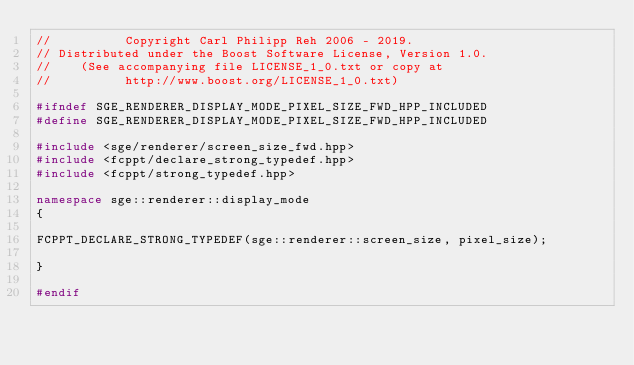<code> <loc_0><loc_0><loc_500><loc_500><_C++_>//          Copyright Carl Philipp Reh 2006 - 2019.
// Distributed under the Boost Software License, Version 1.0.
//    (See accompanying file LICENSE_1_0.txt or copy at
//          http://www.boost.org/LICENSE_1_0.txt)

#ifndef SGE_RENDERER_DISPLAY_MODE_PIXEL_SIZE_FWD_HPP_INCLUDED
#define SGE_RENDERER_DISPLAY_MODE_PIXEL_SIZE_FWD_HPP_INCLUDED

#include <sge/renderer/screen_size_fwd.hpp>
#include <fcppt/declare_strong_typedef.hpp>
#include <fcppt/strong_typedef.hpp>

namespace sge::renderer::display_mode
{

FCPPT_DECLARE_STRONG_TYPEDEF(sge::renderer::screen_size, pixel_size);

}

#endif
</code> 